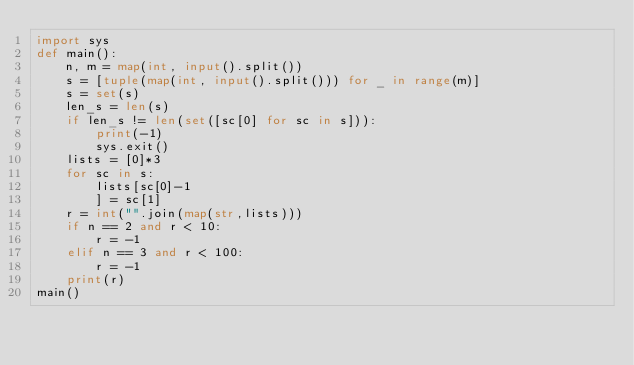Convert code to text. <code><loc_0><loc_0><loc_500><loc_500><_Python_>import sys
def main():
    n, m = map(int, input().split())
    s = [tuple(map(int, input().split())) for _ in range(m)]
    s = set(s)
    len_s = len(s)
    if len_s != len(set([sc[0] for sc in s])):
        print(-1)
        sys.exit()
    lists = [0]*3
    for sc in s:
        lists[sc[0]-1
        ] = sc[1]
    r = int("".join(map(str,lists)))
    if n == 2 and r < 10:
        r = -1
    elif n == 3 and r < 100:
        r = -1
    print(r)
main()</code> 